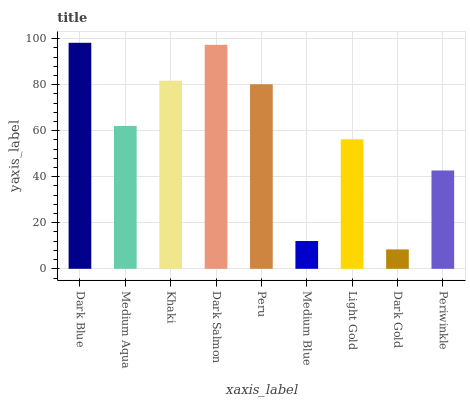Is Medium Aqua the minimum?
Answer yes or no. No. Is Medium Aqua the maximum?
Answer yes or no. No. Is Dark Blue greater than Medium Aqua?
Answer yes or no. Yes. Is Medium Aqua less than Dark Blue?
Answer yes or no. Yes. Is Medium Aqua greater than Dark Blue?
Answer yes or no. No. Is Dark Blue less than Medium Aqua?
Answer yes or no. No. Is Medium Aqua the high median?
Answer yes or no. Yes. Is Medium Aqua the low median?
Answer yes or no. Yes. Is Khaki the high median?
Answer yes or no. No. Is Dark Gold the low median?
Answer yes or no. No. 